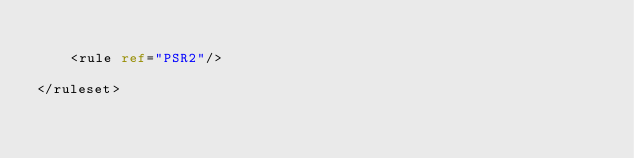Convert code to text. <code><loc_0><loc_0><loc_500><loc_500><_XML_>
    <rule ref="PSR2"/>

</ruleset></code> 